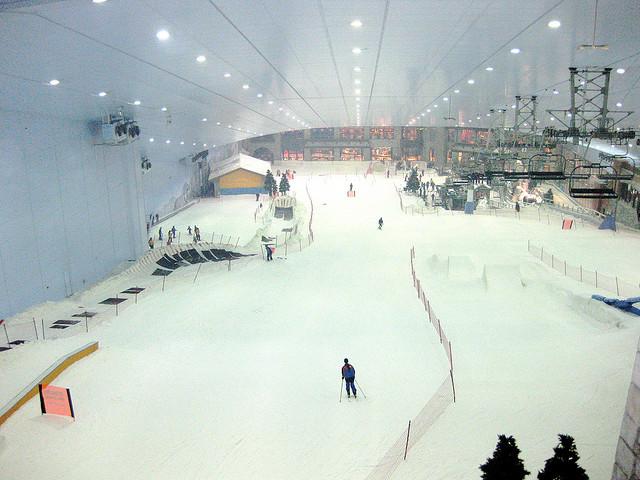What covers the ground?
Keep it brief. Snow. Is this an indoor area?
Answer briefly. Yes. How many skiers can be seen?
Give a very brief answer. 2. 